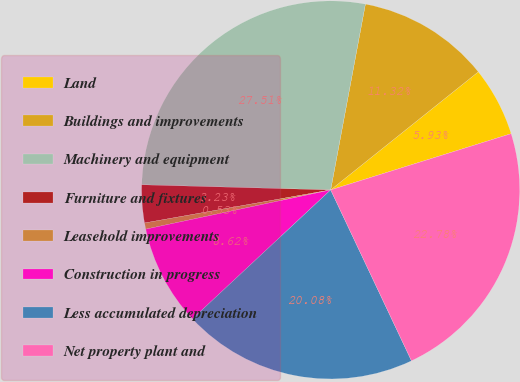<chart> <loc_0><loc_0><loc_500><loc_500><pie_chart><fcel>Land<fcel>Buildings and improvements<fcel>Machinery and equipment<fcel>Furniture and fixtures<fcel>Leasehold improvements<fcel>Construction in progress<fcel>Less accumulated depreciation<fcel>Net property plant and<nl><fcel>5.93%<fcel>11.32%<fcel>27.51%<fcel>3.23%<fcel>0.53%<fcel>8.62%<fcel>20.08%<fcel>22.78%<nl></chart> 